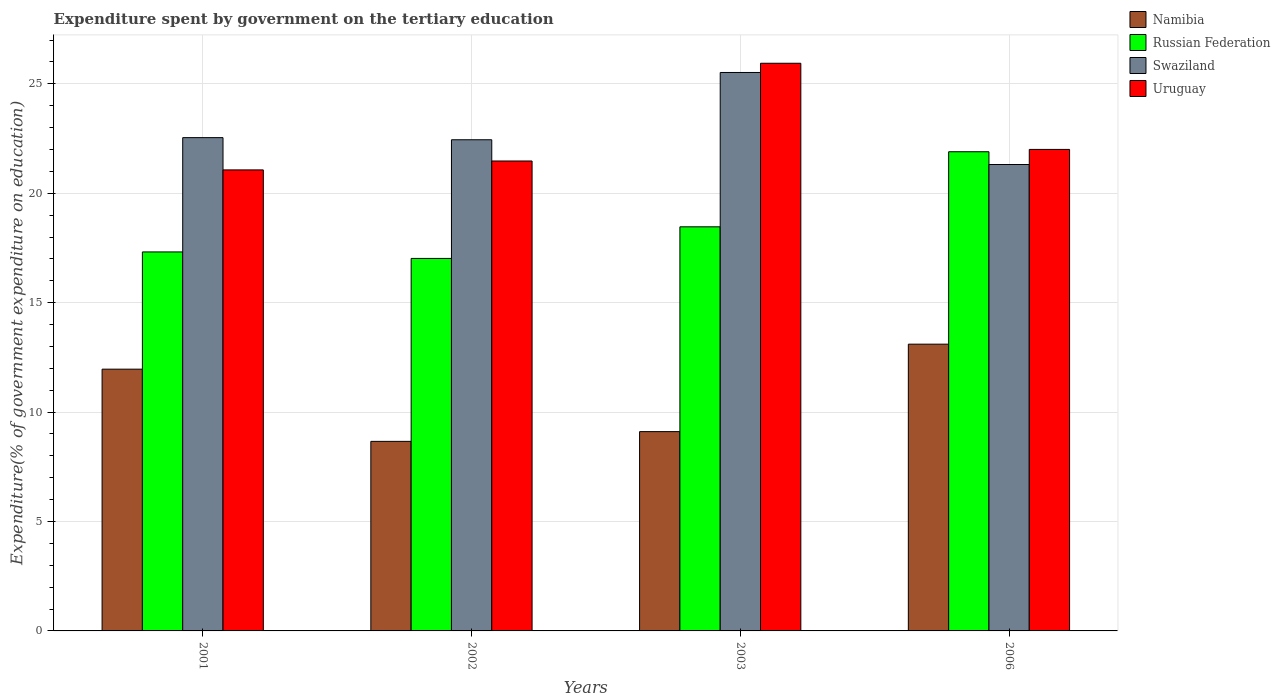Are the number of bars on each tick of the X-axis equal?
Your answer should be compact. Yes. How many bars are there on the 1st tick from the left?
Your answer should be very brief. 4. What is the label of the 2nd group of bars from the left?
Offer a terse response. 2002. What is the expenditure spent by government on the tertiary education in Uruguay in 2003?
Your response must be concise. 25.94. Across all years, what is the maximum expenditure spent by government on the tertiary education in Namibia?
Your answer should be very brief. 13.1. Across all years, what is the minimum expenditure spent by government on the tertiary education in Russian Federation?
Provide a succinct answer. 17.02. In which year was the expenditure spent by government on the tertiary education in Swaziland maximum?
Give a very brief answer. 2003. What is the total expenditure spent by government on the tertiary education in Russian Federation in the graph?
Give a very brief answer. 74.7. What is the difference between the expenditure spent by government on the tertiary education in Namibia in 2003 and that in 2006?
Provide a succinct answer. -4. What is the difference between the expenditure spent by government on the tertiary education in Namibia in 2003 and the expenditure spent by government on the tertiary education in Swaziland in 2002?
Ensure brevity in your answer.  -13.34. What is the average expenditure spent by government on the tertiary education in Uruguay per year?
Your answer should be compact. 22.62. In the year 2003, what is the difference between the expenditure spent by government on the tertiary education in Namibia and expenditure spent by government on the tertiary education in Swaziland?
Your response must be concise. -16.41. What is the ratio of the expenditure spent by government on the tertiary education in Uruguay in 2003 to that in 2006?
Make the answer very short. 1.18. Is the difference between the expenditure spent by government on the tertiary education in Namibia in 2002 and 2003 greater than the difference between the expenditure spent by government on the tertiary education in Swaziland in 2002 and 2003?
Offer a very short reply. Yes. What is the difference between the highest and the second highest expenditure spent by government on the tertiary education in Uruguay?
Make the answer very short. 3.94. What is the difference between the highest and the lowest expenditure spent by government on the tertiary education in Uruguay?
Your response must be concise. 4.87. Is the sum of the expenditure spent by government on the tertiary education in Namibia in 2003 and 2006 greater than the maximum expenditure spent by government on the tertiary education in Swaziland across all years?
Your answer should be compact. No. Is it the case that in every year, the sum of the expenditure spent by government on the tertiary education in Russian Federation and expenditure spent by government on the tertiary education in Uruguay is greater than the sum of expenditure spent by government on the tertiary education in Namibia and expenditure spent by government on the tertiary education in Swaziland?
Offer a very short reply. No. What does the 2nd bar from the left in 2001 represents?
Provide a short and direct response. Russian Federation. What does the 2nd bar from the right in 2006 represents?
Your response must be concise. Swaziland. Is it the case that in every year, the sum of the expenditure spent by government on the tertiary education in Uruguay and expenditure spent by government on the tertiary education in Swaziland is greater than the expenditure spent by government on the tertiary education in Russian Federation?
Offer a terse response. Yes. How many bars are there?
Your response must be concise. 16. How many years are there in the graph?
Provide a succinct answer. 4. Does the graph contain any zero values?
Keep it short and to the point. No. Does the graph contain grids?
Ensure brevity in your answer.  Yes. How many legend labels are there?
Offer a terse response. 4. What is the title of the graph?
Your answer should be compact. Expenditure spent by government on the tertiary education. What is the label or title of the Y-axis?
Offer a very short reply. Expenditure(% of government expenditure on education). What is the Expenditure(% of government expenditure on education) of Namibia in 2001?
Make the answer very short. 11.96. What is the Expenditure(% of government expenditure on education) in Russian Federation in 2001?
Give a very brief answer. 17.32. What is the Expenditure(% of government expenditure on education) in Swaziland in 2001?
Make the answer very short. 22.54. What is the Expenditure(% of government expenditure on education) in Uruguay in 2001?
Keep it short and to the point. 21.07. What is the Expenditure(% of government expenditure on education) in Namibia in 2002?
Give a very brief answer. 8.66. What is the Expenditure(% of government expenditure on education) of Russian Federation in 2002?
Make the answer very short. 17.02. What is the Expenditure(% of government expenditure on education) in Swaziland in 2002?
Keep it short and to the point. 22.44. What is the Expenditure(% of government expenditure on education) of Uruguay in 2002?
Your answer should be very brief. 21.47. What is the Expenditure(% of government expenditure on education) in Namibia in 2003?
Give a very brief answer. 9.11. What is the Expenditure(% of government expenditure on education) in Russian Federation in 2003?
Provide a short and direct response. 18.47. What is the Expenditure(% of government expenditure on education) of Swaziland in 2003?
Provide a succinct answer. 25.52. What is the Expenditure(% of government expenditure on education) of Uruguay in 2003?
Your answer should be very brief. 25.94. What is the Expenditure(% of government expenditure on education) in Namibia in 2006?
Your answer should be very brief. 13.1. What is the Expenditure(% of government expenditure on education) of Russian Federation in 2006?
Offer a very short reply. 21.9. What is the Expenditure(% of government expenditure on education) in Swaziland in 2006?
Your response must be concise. 21.31. What is the Expenditure(% of government expenditure on education) in Uruguay in 2006?
Provide a short and direct response. 22. Across all years, what is the maximum Expenditure(% of government expenditure on education) of Namibia?
Make the answer very short. 13.1. Across all years, what is the maximum Expenditure(% of government expenditure on education) of Russian Federation?
Offer a terse response. 21.9. Across all years, what is the maximum Expenditure(% of government expenditure on education) of Swaziland?
Keep it short and to the point. 25.52. Across all years, what is the maximum Expenditure(% of government expenditure on education) in Uruguay?
Your answer should be very brief. 25.94. Across all years, what is the minimum Expenditure(% of government expenditure on education) in Namibia?
Make the answer very short. 8.66. Across all years, what is the minimum Expenditure(% of government expenditure on education) in Russian Federation?
Your answer should be very brief. 17.02. Across all years, what is the minimum Expenditure(% of government expenditure on education) in Swaziland?
Offer a very short reply. 21.31. Across all years, what is the minimum Expenditure(% of government expenditure on education) in Uruguay?
Ensure brevity in your answer.  21.07. What is the total Expenditure(% of government expenditure on education) of Namibia in the graph?
Ensure brevity in your answer.  42.83. What is the total Expenditure(% of government expenditure on education) in Russian Federation in the graph?
Your response must be concise. 74.7. What is the total Expenditure(% of government expenditure on education) in Swaziland in the graph?
Ensure brevity in your answer.  91.82. What is the total Expenditure(% of government expenditure on education) in Uruguay in the graph?
Your answer should be compact. 90.48. What is the difference between the Expenditure(% of government expenditure on education) of Namibia in 2001 and that in 2002?
Your answer should be compact. 3.3. What is the difference between the Expenditure(% of government expenditure on education) in Russian Federation in 2001 and that in 2002?
Keep it short and to the point. 0.3. What is the difference between the Expenditure(% of government expenditure on education) of Swaziland in 2001 and that in 2002?
Make the answer very short. 0.1. What is the difference between the Expenditure(% of government expenditure on education) in Uruguay in 2001 and that in 2002?
Your answer should be very brief. -0.41. What is the difference between the Expenditure(% of government expenditure on education) of Namibia in 2001 and that in 2003?
Provide a short and direct response. 2.85. What is the difference between the Expenditure(% of government expenditure on education) in Russian Federation in 2001 and that in 2003?
Make the answer very short. -1.15. What is the difference between the Expenditure(% of government expenditure on education) in Swaziland in 2001 and that in 2003?
Provide a succinct answer. -2.98. What is the difference between the Expenditure(% of government expenditure on education) in Uruguay in 2001 and that in 2003?
Provide a short and direct response. -4.87. What is the difference between the Expenditure(% of government expenditure on education) in Namibia in 2001 and that in 2006?
Your answer should be very brief. -1.14. What is the difference between the Expenditure(% of government expenditure on education) in Russian Federation in 2001 and that in 2006?
Give a very brief answer. -4.58. What is the difference between the Expenditure(% of government expenditure on education) of Swaziland in 2001 and that in 2006?
Make the answer very short. 1.23. What is the difference between the Expenditure(% of government expenditure on education) of Uruguay in 2001 and that in 2006?
Your answer should be compact. -0.94. What is the difference between the Expenditure(% of government expenditure on education) in Namibia in 2002 and that in 2003?
Your response must be concise. -0.45. What is the difference between the Expenditure(% of government expenditure on education) in Russian Federation in 2002 and that in 2003?
Provide a short and direct response. -1.44. What is the difference between the Expenditure(% of government expenditure on education) of Swaziland in 2002 and that in 2003?
Provide a short and direct response. -3.07. What is the difference between the Expenditure(% of government expenditure on education) in Uruguay in 2002 and that in 2003?
Make the answer very short. -4.47. What is the difference between the Expenditure(% of government expenditure on education) in Namibia in 2002 and that in 2006?
Give a very brief answer. -4.44. What is the difference between the Expenditure(% of government expenditure on education) in Russian Federation in 2002 and that in 2006?
Offer a very short reply. -4.88. What is the difference between the Expenditure(% of government expenditure on education) in Swaziland in 2002 and that in 2006?
Keep it short and to the point. 1.13. What is the difference between the Expenditure(% of government expenditure on education) of Uruguay in 2002 and that in 2006?
Your response must be concise. -0.53. What is the difference between the Expenditure(% of government expenditure on education) in Namibia in 2003 and that in 2006?
Ensure brevity in your answer.  -4. What is the difference between the Expenditure(% of government expenditure on education) in Russian Federation in 2003 and that in 2006?
Give a very brief answer. -3.43. What is the difference between the Expenditure(% of government expenditure on education) in Swaziland in 2003 and that in 2006?
Keep it short and to the point. 4.21. What is the difference between the Expenditure(% of government expenditure on education) in Uruguay in 2003 and that in 2006?
Your answer should be very brief. 3.94. What is the difference between the Expenditure(% of government expenditure on education) in Namibia in 2001 and the Expenditure(% of government expenditure on education) in Russian Federation in 2002?
Make the answer very short. -5.06. What is the difference between the Expenditure(% of government expenditure on education) of Namibia in 2001 and the Expenditure(% of government expenditure on education) of Swaziland in 2002?
Keep it short and to the point. -10.48. What is the difference between the Expenditure(% of government expenditure on education) in Namibia in 2001 and the Expenditure(% of government expenditure on education) in Uruguay in 2002?
Offer a very short reply. -9.51. What is the difference between the Expenditure(% of government expenditure on education) in Russian Federation in 2001 and the Expenditure(% of government expenditure on education) in Swaziland in 2002?
Your answer should be very brief. -5.13. What is the difference between the Expenditure(% of government expenditure on education) in Russian Federation in 2001 and the Expenditure(% of government expenditure on education) in Uruguay in 2002?
Provide a succinct answer. -4.16. What is the difference between the Expenditure(% of government expenditure on education) in Swaziland in 2001 and the Expenditure(% of government expenditure on education) in Uruguay in 2002?
Provide a short and direct response. 1.07. What is the difference between the Expenditure(% of government expenditure on education) of Namibia in 2001 and the Expenditure(% of government expenditure on education) of Russian Federation in 2003?
Give a very brief answer. -6.5. What is the difference between the Expenditure(% of government expenditure on education) of Namibia in 2001 and the Expenditure(% of government expenditure on education) of Swaziland in 2003?
Provide a short and direct response. -13.56. What is the difference between the Expenditure(% of government expenditure on education) of Namibia in 2001 and the Expenditure(% of government expenditure on education) of Uruguay in 2003?
Offer a terse response. -13.98. What is the difference between the Expenditure(% of government expenditure on education) in Russian Federation in 2001 and the Expenditure(% of government expenditure on education) in Uruguay in 2003?
Ensure brevity in your answer.  -8.62. What is the difference between the Expenditure(% of government expenditure on education) in Swaziland in 2001 and the Expenditure(% of government expenditure on education) in Uruguay in 2003?
Keep it short and to the point. -3.4. What is the difference between the Expenditure(% of government expenditure on education) in Namibia in 2001 and the Expenditure(% of government expenditure on education) in Russian Federation in 2006?
Give a very brief answer. -9.94. What is the difference between the Expenditure(% of government expenditure on education) of Namibia in 2001 and the Expenditure(% of government expenditure on education) of Swaziland in 2006?
Provide a short and direct response. -9.35. What is the difference between the Expenditure(% of government expenditure on education) of Namibia in 2001 and the Expenditure(% of government expenditure on education) of Uruguay in 2006?
Make the answer very short. -10.04. What is the difference between the Expenditure(% of government expenditure on education) in Russian Federation in 2001 and the Expenditure(% of government expenditure on education) in Swaziland in 2006?
Your response must be concise. -4. What is the difference between the Expenditure(% of government expenditure on education) of Russian Federation in 2001 and the Expenditure(% of government expenditure on education) of Uruguay in 2006?
Offer a very short reply. -4.68. What is the difference between the Expenditure(% of government expenditure on education) of Swaziland in 2001 and the Expenditure(% of government expenditure on education) of Uruguay in 2006?
Your answer should be compact. 0.54. What is the difference between the Expenditure(% of government expenditure on education) in Namibia in 2002 and the Expenditure(% of government expenditure on education) in Russian Federation in 2003?
Offer a terse response. -9.8. What is the difference between the Expenditure(% of government expenditure on education) in Namibia in 2002 and the Expenditure(% of government expenditure on education) in Swaziland in 2003?
Ensure brevity in your answer.  -16.86. What is the difference between the Expenditure(% of government expenditure on education) of Namibia in 2002 and the Expenditure(% of government expenditure on education) of Uruguay in 2003?
Ensure brevity in your answer.  -17.28. What is the difference between the Expenditure(% of government expenditure on education) of Russian Federation in 2002 and the Expenditure(% of government expenditure on education) of Swaziland in 2003?
Your answer should be very brief. -8.5. What is the difference between the Expenditure(% of government expenditure on education) in Russian Federation in 2002 and the Expenditure(% of government expenditure on education) in Uruguay in 2003?
Your answer should be compact. -8.92. What is the difference between the Expenditure(% of government expenditure on education) in Swaziland in 2002 and the Expenditure(% of government expenditure on education) in Uruguay in 2003?
Provide a succinct answer. -3.5. What is the difference between the Expenditure(% of government expenditure on education) in Namibia in 2002 and the Expenditure(% of government expenditure on education) in Russian Federation in 2006?
Keep it short and to the point. -13.23. What is the difference between the Expenditure(% of government expenditure on education) in Namibia in 2002 and the Expenditure(% of government expenditure on education) in Swaziland in 2006?
Offer a very short reply. -12.65. What is the difference between the Expenditure(% of government expenditure on education) in Namibia in 2002 and the Expenditure(% of government expenditure on education) in Uruguay in 2006?
Keep it short and to the point. -13.34. What is the difference between the Expenditure(% of government expenditure on education) of Russian Federation in 2002 and the Expenditure(% of government expenditure on education) of Swaziland in 2006?
Your answer should be very brief. -4.29. What is the difference between the Expenditure(% of government expenditure on education) in Russian Federation in 2002 and the Expenditure(% of government expenditure on education) in Uruguay in 2006?
Your answer should be very brief. -4.98. What is the difference between the Expenditure(% of government expenditure on education) of Swaziland in 2002 and the Expenditure(% of government expenditure on education) of Uruguay in 2006?
Provide a short and direct response. 0.44. What is the difference between the Expenditure(% of government expenditure on education) in Namibia in 2003 and the Expenditure(% of government expenditure on education) in Russian Federation in 2006?
Provide a short and direct response. -12.79. What is the difference between the Expenditure(% of government expenditure on education) in Namibia in 2003 and the Expenditure(% of government expenditure on education) in Swaziland in 2006?
Your answer should be compact. -12.21. What is the difference between the Expenditure(% of government expenditure on education) in Namibia in 2003 and the Expenditure(% of government expenditure on education) in Uruguay in 2006?
Provide a succinct answer. -12.89. What is the difference between the Expenditure(% of government expenditure on education) of Russian Federation in 2003 and the Expenditure(% of government expenditure on education) of Swaziland in 2006?
Provide a succinct answer. -2.85. What is the difference between the Expenditure(% of government expenditure on education) of Russian Federation in 2003 and the Expenditure(% of government expenditure on education) of Uruguay in 2006?
Offer a very short reply. -3.54. What is the difference between the Expenditure(% of government expenditure on education) of Swaziland in 2003 and the Expenditure(% of government expenditure on education) of Uruguay in 2006?
Provide a succinct answer. 3.52. What is the average Expenditure(% of government expenditure on education) of Namibia per year?
Ensure brevity in your answer.  10.71. What is the average Expenditure(% of government expenditure on education) in Russian Federation per year?
Offer a very short reply. 18.68. What is the average Expenditure(% of government expenditure on education) of Swaziland per year?
Make the answer very short. 22.95. What is the average Expenditure(% of government expenditure on education) of Uruguay per year?
Your response must be concise. 22.62. In the year 2001, what is the difference between the Expenditure(% of government expenditure on education) in Namibia and Expenditure(% of government expenditure on education) in Russian Federation?
Offer a very short reply. -5.36. In the year 2001, what is the difference between the Expenditure(% of government expenditure on education) of Namibia and Expenditure(% of government expenditure on education) of Swaziland?
Offer a terse response. -10.58. In the year 2001, what is the difference between the Expenditure(% of government expenditure on education) of Namibia and Expenditure(% of government expenditure on education) of Uruguay?
Ensure brevity in your answer.  -9.11. In the year 2001, what is the difference between the Expenditure(% of government expenditure on education) in Russian Federation and Expenditure(% of government expenditure on education) in Swaziland?
Provide a short and direct response. -5.22. In the year 2001, what is the difference between the Expenditure(% of government expenditure on education) of Russian Federation and Expenditure(% of government expenditure on education) of Uruguay?
Offer a terse response. -3.75. In the year 2001, what is the difference between the Expenditure(% of government expenditure on education) in Swaziland and Expenditure(% of government expenditure on education) in Uruguay?
Keep it short and to the point. 1.47. In the year 2002, what is the difference between the Expenditure(% of government expenditure on education) in Namibia and Expenditure(% of government expenditure on education) in Russian Federation?
Your answer should be very brief. -8.36. In the year 2002, what is the difference between the Expenditure(% of government expenditure on education) in Namibia and Expenditure(% of government expenditure on education) in Swaziland?
Provide a succinct answer. -13.78. In the year 2002, what is the difference between the Expenditure(% of government expenditure on education) of Namibia and Expenditure(% of government expenditure on education) of Uruguay?
Your answer should be very brief. -12.81. In the year 2002, what is the difference between the Expenditure(% of government expenditure on education) of Russian Federation and Expenditure(% of government expenditure on education) of Swaziland?
Make the answer very short. -5.42. In the year 2002, what is the difference between the Expenditure(% of government expenditure on education) in Russian Federation and Expenditure(% of government expenditure on education) in Uruguay?
Offer a terse response. -4.45. In the year 2002, what is the difference between the Expenditure(% of government expenditure on education) of Swaziland and Expenditure(% of government expenditure on education) of Uruguay?
Give a very brief answer. 0.97. In the year 2003, what is the difference between the Expenditure(% of government expenditure on education) in Namibia and Expenditure(% of government expenditure on education) in Russian Federation?
Give a very brief answer. -9.36. In the year 2003, what is the difference between the Expenditure(% of government expenditure on education) of Namibia and Expenditure(% of government expenditure on education) of Swaziland?
Provide a short and direct response. -16.41. In the year 2003, what is the difference between the Expenditure(% of government expenditure on education) of Namibia and Expenditure(% of government expenditure on education) of Uruguay?
Your response must be concise. -16.83. In the year 2003, what is the difference between the Expenditure(% of government expenditure on education) of Russian Federation and Expenditure(% of government expenditure on education) of Swaziland?
Keep it short and to the point. -7.05. In the year 2003, what is the difference between the Expenditure(% of government expenditure on education) of Russian Federation and Expenditure(% of government expenditure on education) of Uruguay?
Give a very brief answer. -7.47. In the year 2003, what is the difference between the Expenditure(% of government expenditure on education) of Swaziland and Expenditure(% of government expenditure on education) of Uruguay?
Offer a terse response. -0.42. In the year 2006, what is the difference between the Expenditure(% of government expenditure on education) of Namibia and Expenditure(% of government expenditure on education) of Russian Federation?
Ensure brevity in your answer.  -8.79. In the year 2006, what is the difference between the Expenditure(% of government expenditure on education) in Namibia and Expenditure(% of government expenditure on education) in Swaziland?
Provide a succinct answer. -8.21. In the year 2006, what is the difference between the Expenditure(% of government expenditure on education) of Namibia and Expenditure(% of government expenditure on education) of Uruguay?
Provide a succinct answer. -8.9. In the year 2006, what is the difference between the Expenditure(% of government expenditure on education) of Russian Federation and Expenditure(% of government expenditure on education) of Swaziland?
Keep it short and to the point. 0.58. In the year 2006, what is the difference between the Expenditure(% of government expenditure on education) of Russian Federation and Expenditure(% of government expenditure on education) of Uruguay?
Your answer should be compact. -0.11. In the year 2006, what is the difference between the Expenditure(% of government expenditure on education) in Swaziland and Expenditure(% of government expenditure on education) in Uruguay?
Keep it short and to the point. -0.69. What is the ratio of the Expenditure(% of government expenditure on education) in Namibia in 2001 to that in 2002?
Provide a succinct answer. 1.38. What is the ratio of the Expenditure(% of government expenditure on education) in Russian Federation in 2001 to that in 2002?
Your answer should be very brief. 1.02. What is the ratio of the Expenditure(% of government expenditure on education) in Uruguay in 2001 to that in 2002?
Your answer should be very brief. 0.98. What is the ratio of the Expenditure(% of government expenditure on education) of Namibia in 2001 to that in 2003?
Provide a succinct answer. 1.31. What is the ratio of the Expenditure(% of government expenditure on education) of Russian Federation in 2001 to that in 2003?
Provide a short and direct response. 0.94. What is the ratio of the Expenditure(% of government expenditure on education) in Swaziland in 2001 to that in 2003?
Make the answer very short. 0.88. What is the ratio of the Expenditure(% of government expenditure on education) in Uruguay in 2001 to that in 2003?
Offer a very short reply. 0.81. What is the ratio of the Expenditure(% of government expenditure on education) of Namibia in 2001 to that in 2006?
Offer a terse response. 0.91. What is the ratio of the Expenditure(% of government expenditure on education) in Russian Federation in 2001 to that in 2006?
Provide a short and direct response. 0.79. What is the ratio of the Expenditure(% of government expenditure on education) in Swaziland in 2001 to that in 2006?
Ensure brevity in your answer.  1.06. What is the ratio of the Expenditure(% of government expenditure on education) in Uruguay in 2001 to that in 2006?
Offer a very short reply. 0.96. What is the ratio of the Expenditure(% of government expenditure on education) in Namibia in 2002 to that in 2003?
Your answer should be compact. 0.95. What is the ratio of the Expenditure(% of government expenditure on education) in Russian Federation in 2002 to that in 2003?
Provide a short and direct response. 0.92. What is the ratio of the Expenditure(% of government expenditure on education) of Swaziland in 2002 to that in 2003?
Your answer should be compact. 0.88. What is the ratio of the Expenditure(% of government expenditure on education) of Uruguay in 2002 to that in 2003?
Keep it short and to the point. 0.83. What is the ratio of the Expenditure(% of government expenditure on education) of Namibia in 2002 to that in 2006?
Your answer should be compact. 0.66. What is the ratio of the Expenditure(% of government expenditure on education) in Russian Federation in 2002 to that in 2006?
Give a very brief answer. 0.78. What is the ratio of the Expenditure(% of government expenditure on education) in Swaziland in 2002 to that in 2006?
Make the answer very short. 1.05. What is the ratio of the Expenditure(% of government expenditure on education) of Namibia in 2003 to that in 2006?
Your response must be concise. 0.69. What is the ratio of the Expenditure(% of government expenditure on education) of Russian Federation in 2003 to that in 2006?
Provide a short and direct response. 0.84. What is the ratio of the Expenditure(% of government expenditure on education) in Swaziland in 2003 to that in 2006?
Make the answer very short. 1.2. What is the ratio of the Expenditure(% of government expenditure on education) in Uruguay in 2003 to that in 2006?
Ensure brevity in your answer.  1.18. What is the difference between the highest and the second highest Expenditure(% of government expenditure on education) of Namibia?
Your answer should be compact. 1.14. What is the difference between the highest and the second highest Expenditure(% of government expenditure on education) in Russian Federation?
Ensure brevity in your answer.  3.43. What is the difference between the highest and the second highest Expenditure(% of government expenditure on education) in Swaziland?
Provide a succinct answer. 2.98. What is the difference between the highest and the second highest Expenditure(% of government expenditure on education) in Uruguay?
Keep it short and to the point. 3.94. What is the difference between the highest and the lowest Expenditure(% of government expenditure on education) in Namibia?
Provide a succinct answer. 4.44. What is the difference between the highest and the lowest Expenditure(% of government expenditure on education) in Russian Federation?
Give a very brief answer. 4.88. What is the difference between the highest and the lowest Expenditure(% of government expenditure on education) of Swaziland?
Your response must be concise. 4.21. What is the difference between the highest and the lowest Expenditure(% of government expenditure on education) of Uruguay?
Your answer should be compact. 4.87. 